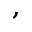<formula> <loc_0><loc_0><loc_500><loc_500>^ { , }</formula> 